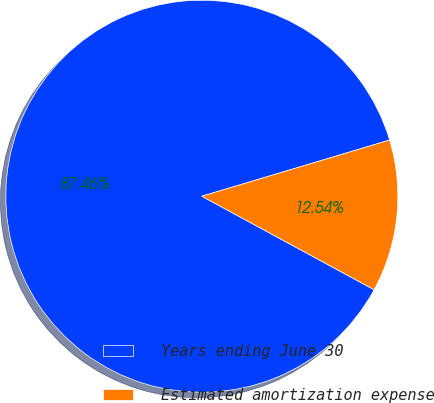Convert chart. <chart><loc_0><loc_0><loc_500><loc_500><pie_chart><fcel>Years ending June 30<fcel>Estimated amortization expense<nl><fcel>87.46%<fcel>12.54%<nl></chart> 